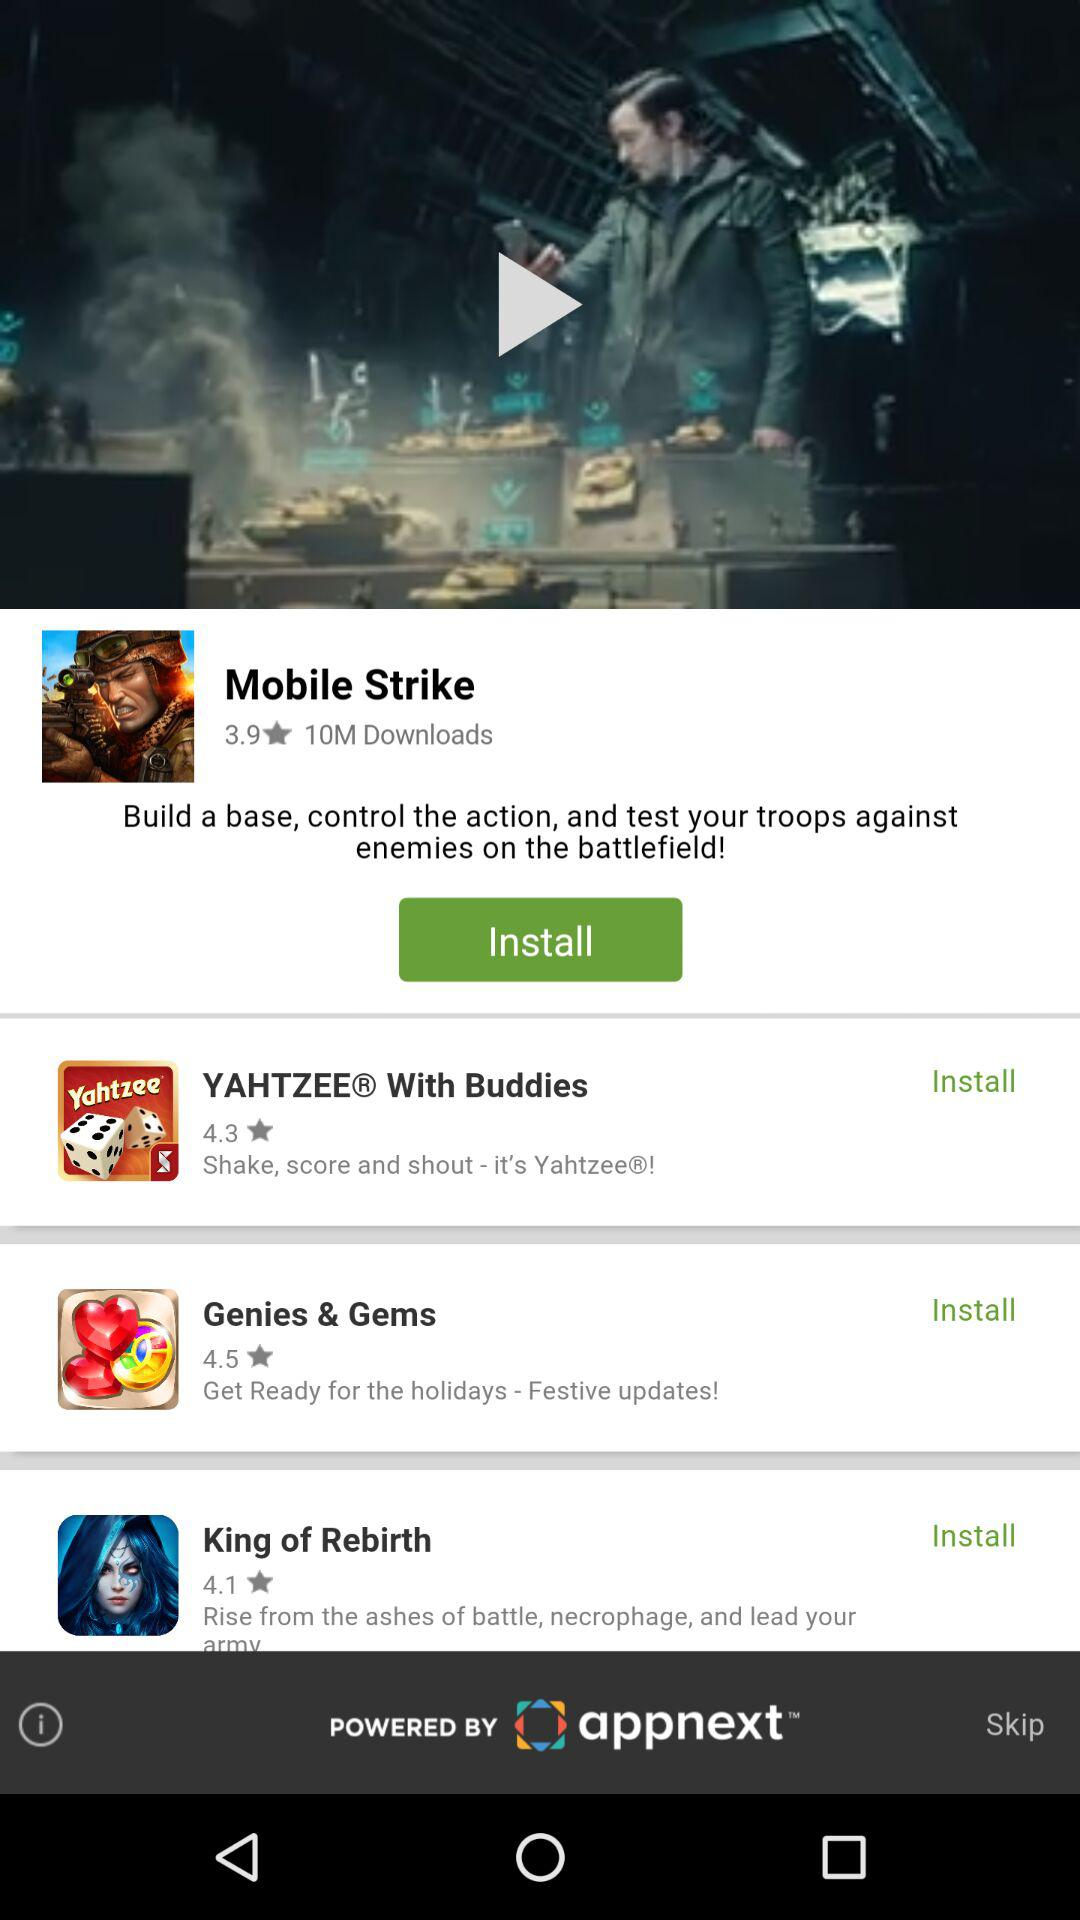How many downloads of "Mobile Strike" are there? There are 10 million downloads of "Mobile Strike". 